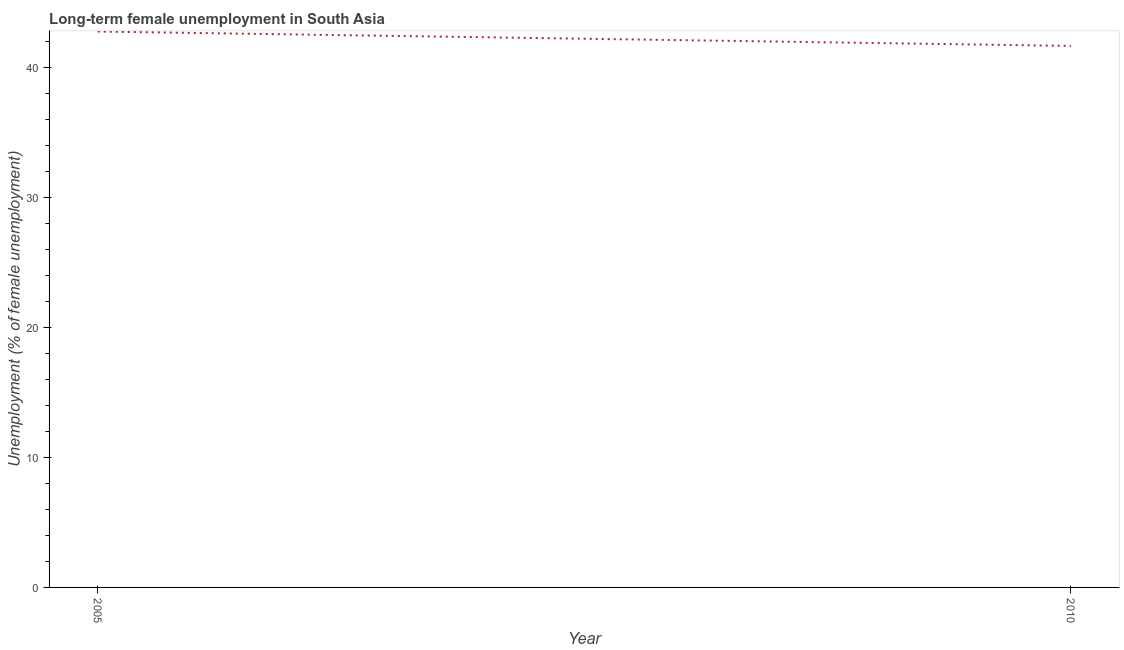What is the long-term female unemployment in 2010?
Your response must be concise. 41.69. Across all years, what is the maximum long-term female unemployment?
Your answer should be compact. 42.8. Across all years, what is the minimum long-term female unemployment?
Your answer should be very brief. 41.69. In which year was the long-term female unemployment minimum?
Your response must be concise. 2010. What is the sum of the long-term female unemployment?
Offer a very short reply. 84.49. What is the difference between the long-term female unemployment in 2005 and 2010?
Your answer should be very brief. 1.11. What is the average long-term female unemployment per year?
Offer a terse response. 42.25. What is the median long-term female unemployment?
Provide a short and direct response. 42.25. In how many years, is the long-term female unemployment greater than 2 %?
Offer a terse response. 2. What is the ratio of the long-term female unemployment in 2005 to that in 2010?
Ensure brevity in your answer.  1.03. Is the long-term female unemployment in 2005 less than that in 2010?
Give a very brief answer. No. What is the difference between two consecutive major ticks on the Y-axis?
Your answer should be very brief. 10. What is the title of the graph?
Your answer should be compact. Long-term female unemployment in South Asia. What is the label or title of the Y-axis?
Your response must be concise. Unemployment (% of female unemployment). What is the Unemployment (% of female unemployment) in 2005?
Your answer should be compact. 42.8. What is the Unemployment (% of female unemployment) of 2010?
Your answer should be compact. 41.69. What is the difference between the Unemployment (% of female unemployment) in 2005 and 2010?
Keep it short and to the point. 1.11. 